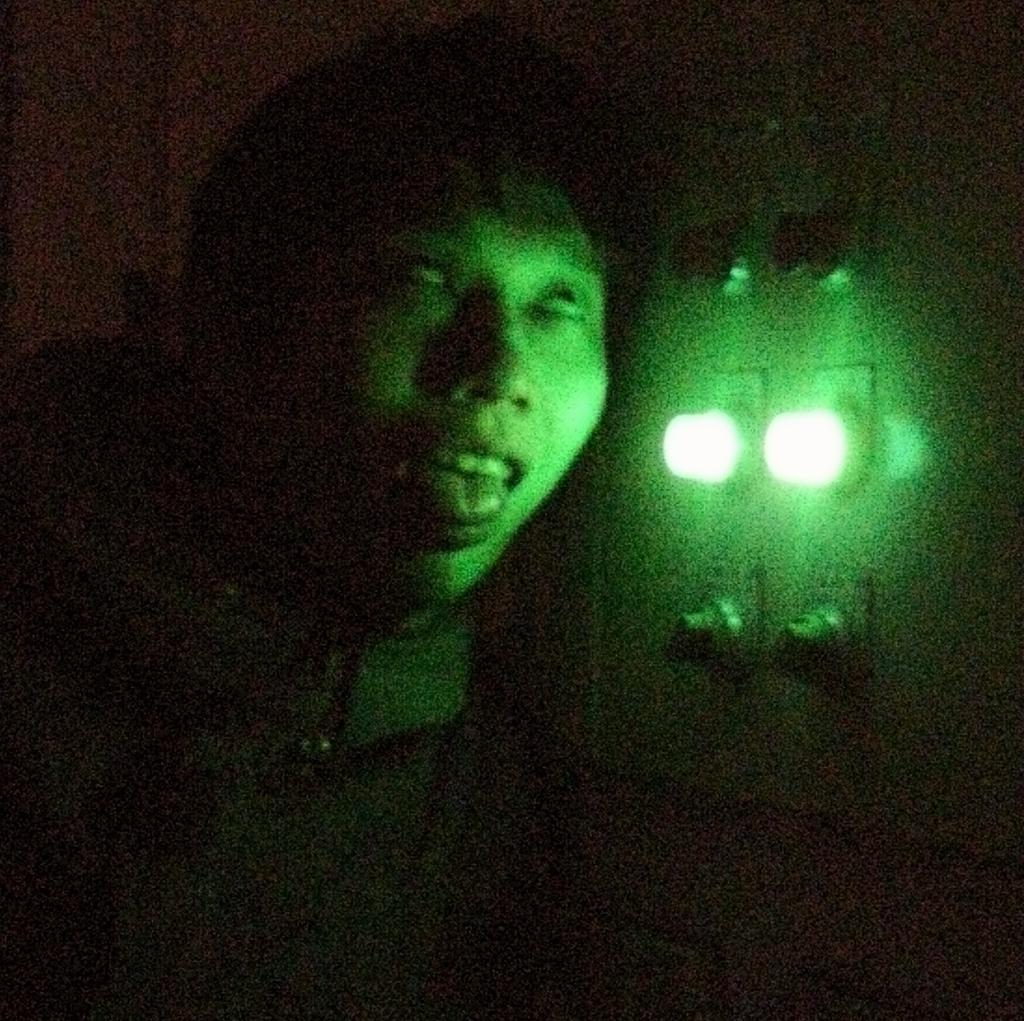Who or what is present in the image? There is a person in the image. What can be seen in the background of the image? There are two lights in the background of the image. What color are the lights in the image? The lights are green in color. What type of nerve is responsible for the person's ability to reason in the image? There is no information about the person's nervous system or reasoning abilities in the image, so we cannot determine which nerve is responsible. 